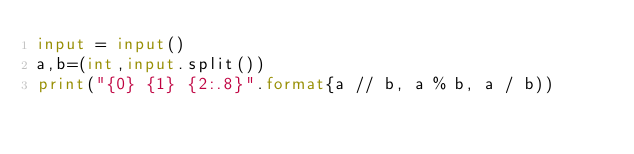Convert code to text. <code><loc_0><loc_0><loc_500><loc_500><_Python_>input = input()
a,b=(int,input.split())
print("{0} {1} {2:.8}".format{a // b, a % b, a / b))

</code> 